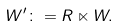Convert formula to latex. <formula><loc_0><loc_0><loc_500><loc_500>W ^ { \prime } \colon = R \ltimes W .</formula> 